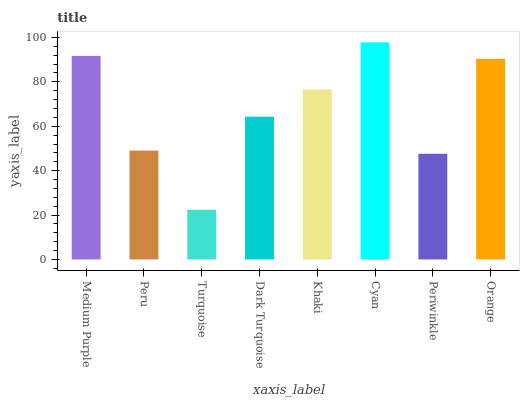Is Turquoise the minimum?
Answer yes or no. Yes. Is Cyan the maximum?
Answer yes or no. Yes. Is Peru the minimum?
Answer yes or no. No. Is Peru the maximum?
Answer yes or no. No. Is Medium Purple greater than Peru?
Answer yes or no. Yes. Is Peru less than Medium Purple?
Answer yes or no. Yes. Is Peru greater than Medium Purple?
Answer yes or no. No. Is Medium Purple less than Peru?
Answer yes or no. No. Is Khaki the high median?
Answer yes or no. Yes. Is Dark Turquoise the low median?
Answer yes or no. Yes. Is Peru the high median?
Answer yes or no. No. Is Periwinkle the low median?
Answer yes or no. No. 